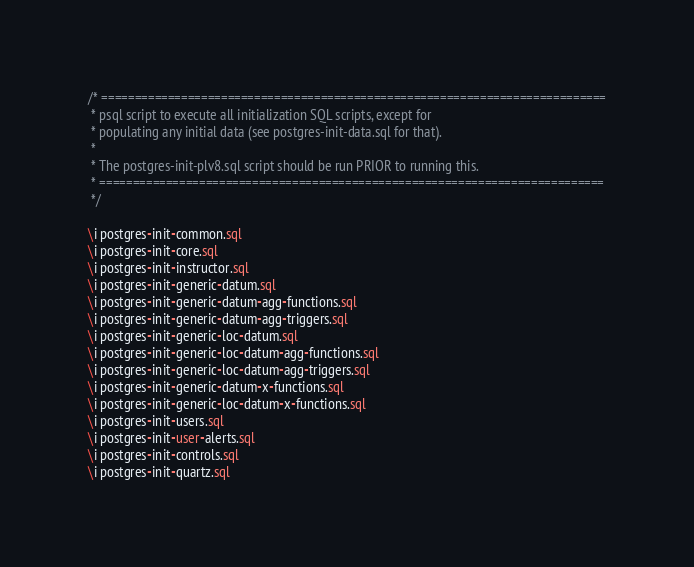Convert code to text. <code><loc_0><loc_0><loc_500><loc_500><_SQL_>/* ============================================================================
 * psql script to execute all initialization SQL scripts, except for
 * populating any initial data (see postgres-init-data.sql for that).
 *
 * The postgres-init-plv8.sql script should be run PRIOR to running this.
 * ============================================================================
 */

\i postgres-init-common.sql
\i postgres-init-core.sql
\i postgres-init-instructor.sql
\i postgres-init-generic-datum.sql
\i postgres-init-generic-datum-agg-functions.sql
\i postgres-init-generic-datum-agg-triggers.sql
\i postgres-init-generic-loc-datum.sql
\i postgres-init-generic-loc-datum-agg-functions.sql
\i postgres-init-generic-loc-datum-agg-triggers.sql
\i postgres-init-generic-datum-x-functions.sql
\i postgres-init-generic-loc-datum-x-functions.sql
\i postgres-init-users.sql
\i postgres-init-user-alerts.sql
\i postgres-init-controls.sql
\i postgres-init-quartz.sql
</code> 